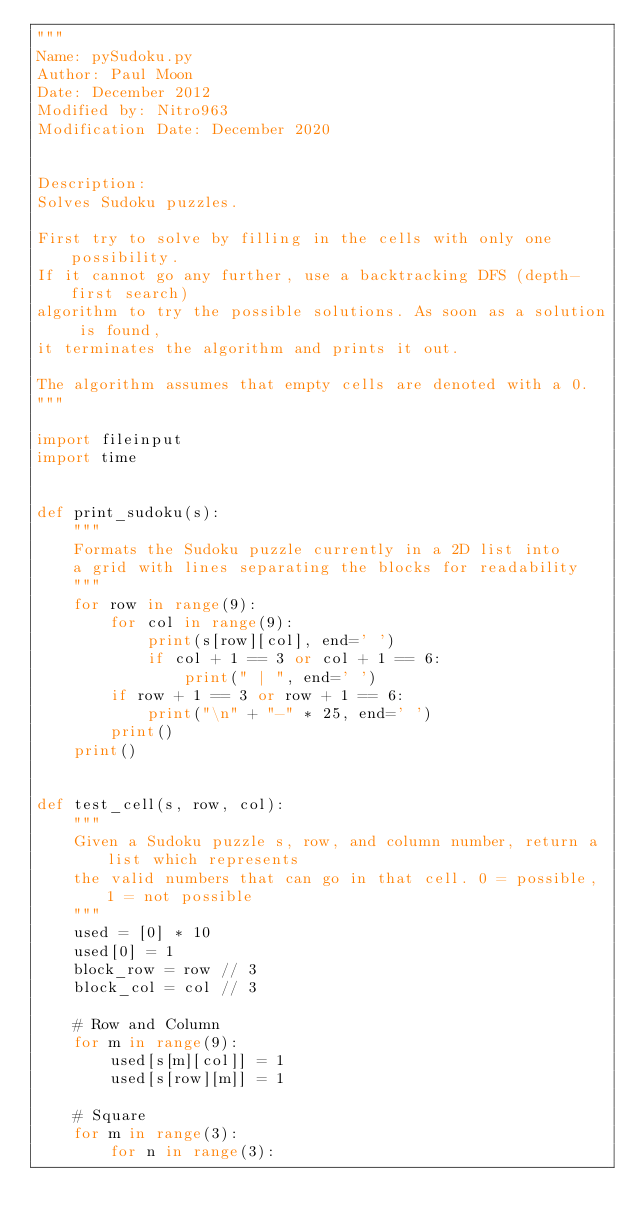Convert code to text. <code><loc_0><loc_0><loc_500><loc_500><_Python_>"""
Name: pySudoku.py
Author: Paul Moon
Date: December 2012
Modified by: Nitro963
Modification Date: December 2020


Description:
Solves Sudoku puzzles.

First try to solve by filling in the cells with only one possibility.
If it cannot go any further, use a backtracking DFS (depth-first search)
algorithm to try the possible solutions. As soon as a solution is found,
it terminates the algorithm and prints it out.

The algorithm assumes that empty cells are denoted with a 0.
"""

import fileinput
import time


def print_sudoku(s):
    """
    Formats the Sudoku puzzle currently in a 2D list into
    a grid with lines separating the blocks for readability
    """
    for row in range(9):
        for col in range(9):
            print(s[row][col], end=' ')
            if col + 1 == 3 or col + 1 == 6:
                print(" | ", end=' ')
        if row + 1 == 3 or row + 1 == 6:
            print("\n" + "-" * 25, end=' ')
        print()
    print()


def test_cell(s, row, col):
    """
    Given a Sudoku puzzle s, row, and column number, return a list which represents
    the valid numbers that can go in that cell. 0 = possible, 1 = not possible
    """
    used = [0] * 10
    used[0] = 1
    block_row = row // 3
    block_col = col // 3

    # Row and Column
    for m in range(9):
        used[s[m][col]] = 1
        used[s[row][m]] = 1

    # Square
    for m in range(3):
        for n in range(3):</code> 